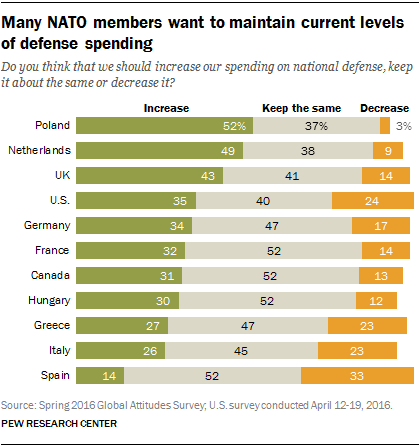Draw attention to some important aspects in this diagram. People in the US who want to increase spending have a higher desire than those who want to decrease spending, with a difference of 0.11. Spain is the country that is willing to decrease spending the most. 